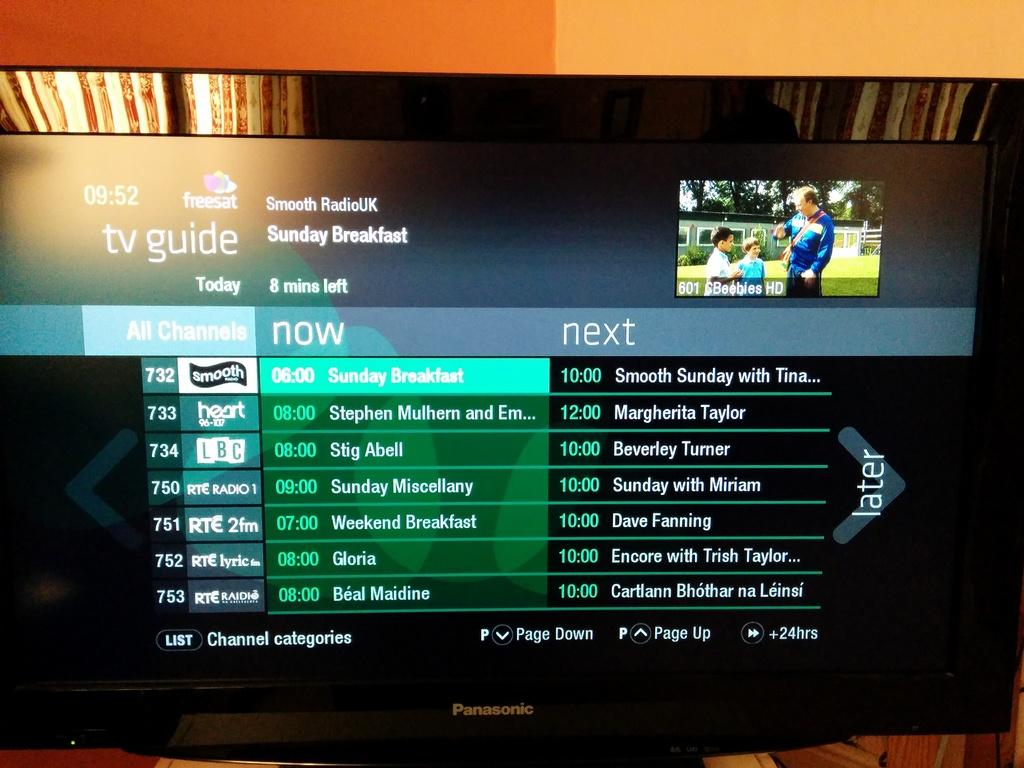Provide a one-sentence caption for the provided image. The tv guide is displaying radio programs that are currently available. 